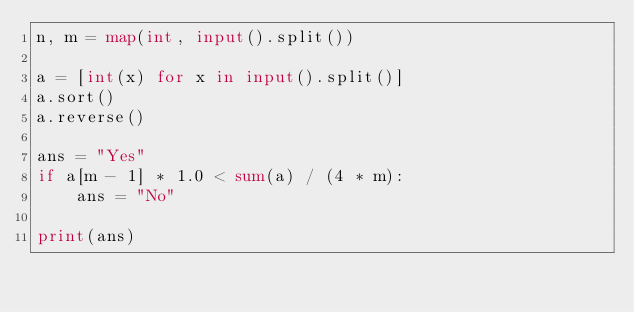Convert code to text. <code><loc_0><loc_0><loc_500><loc_500><_Python_>n, m = map(int, input().split())

a = [int(x) for x in input().split()]
a.sort()
a.reverse()

ans = "Yes"
if a[m - 1] * 1.0 < sum(a) / (4 * m):
    ans = "No"

print(ans)
</code> 